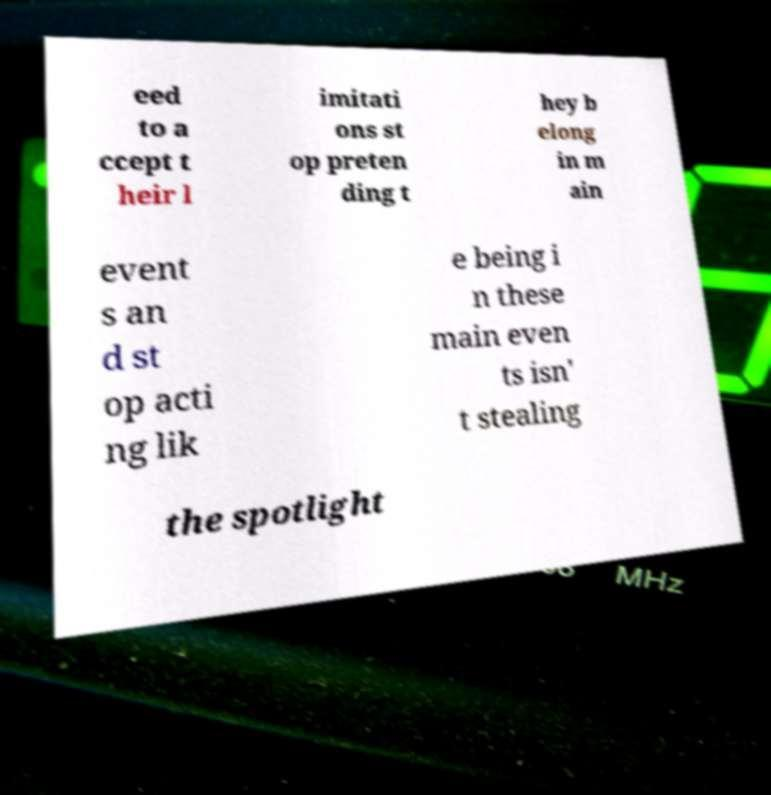Can you accurately transcribe the text from the provided image for me? eed to a ccept t heir l imitati ons st op preten ding t hey b elong in m ain event s an d st op acti ng lik e being i n these main even ts isn' t stealing the spotlight 